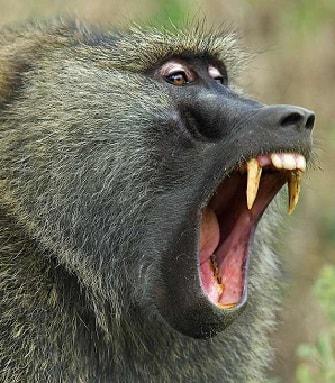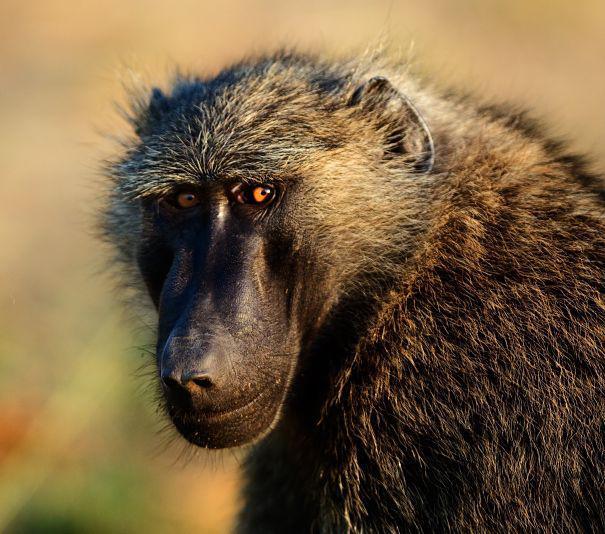The first image is the image on the left, the second image is the image on the right. Evaluate the accuracy of this statement regarding the images: "There are exactly three monkeys". Is it true? Answer yes or no. No. The first image is the image on the left, the second image is the image on the right. For the images displayed, is the sentence "One image features a baby baboon next to an adult baboon" factually correct? Answer yes or no. No. 